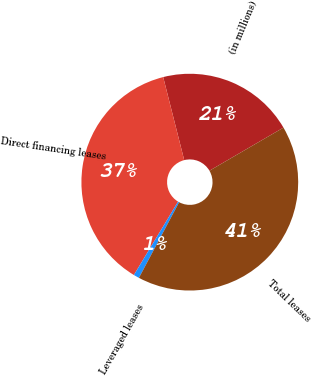Convert chart to OTSL. <chart><loc_0><loc_0><loc_500><loc_500><pie_chart><fcel>(in millions)<fcel>Direct financing leases<fcel>Leveraged leases<fcel>Total leases<nl><fcel>20.56%<fcel>37.43%<fcel>0.85%<fcel>41.17%<nl></chart> 